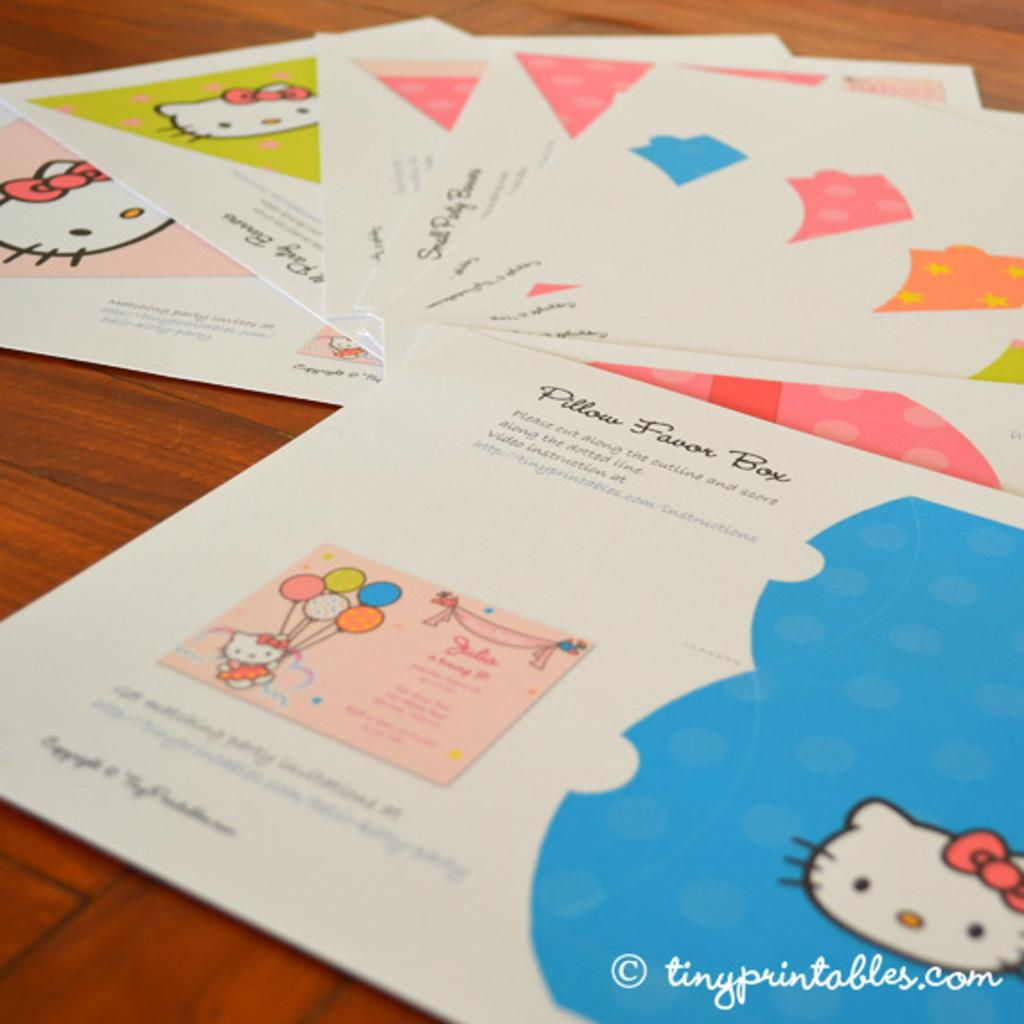<image>
Describe the image concisely. Different papers with cat pictures are on a table and one reads Pillow Favor Box. 